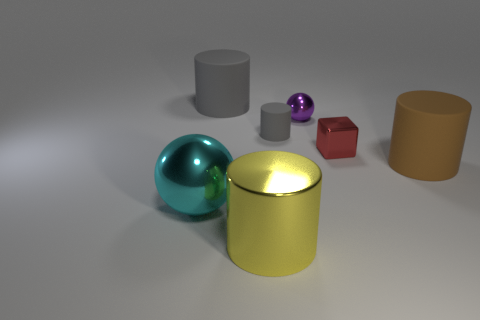What size is the rubber thing that is the same color as the tiny cylinder?
Offer a terse response. Large. Is the color of the cylinder that is in front of the brown rubber object the same as the large matte cylinder behind the large brown cylinder?
Provide a succinct answer. No. How many things are cyan metallic balls or tiny metallic spheres?
Make the answer very short. 2. What number of other things are the same shape as the tiny purple thing?
Your answer should be very brief. 1. Is the gray cylinder to the right of the large yellow object made of the same material as the ball behind the tiny gray rubber thing?
Give a very brief answer. No. What shape is the object that is behind the tiny gray rubber cylinder and to the right of the tiny cylinder?
Make the answer very short. Sphere. Is there any other thing that has the same material as the yellow object?
Keep it short and to the point. Yes. There is a object that is both on the left side of the yellow metallic thing and behind the big cyan shiny object; what material is it?
Make the answer very short. Rubber. What shape is the red object that is made of the same material as the tiny purple sphere?
Keep it short and to the point. Cube. Is there anything else that is the same color as the small block?
Your answer should be very brief. No. 